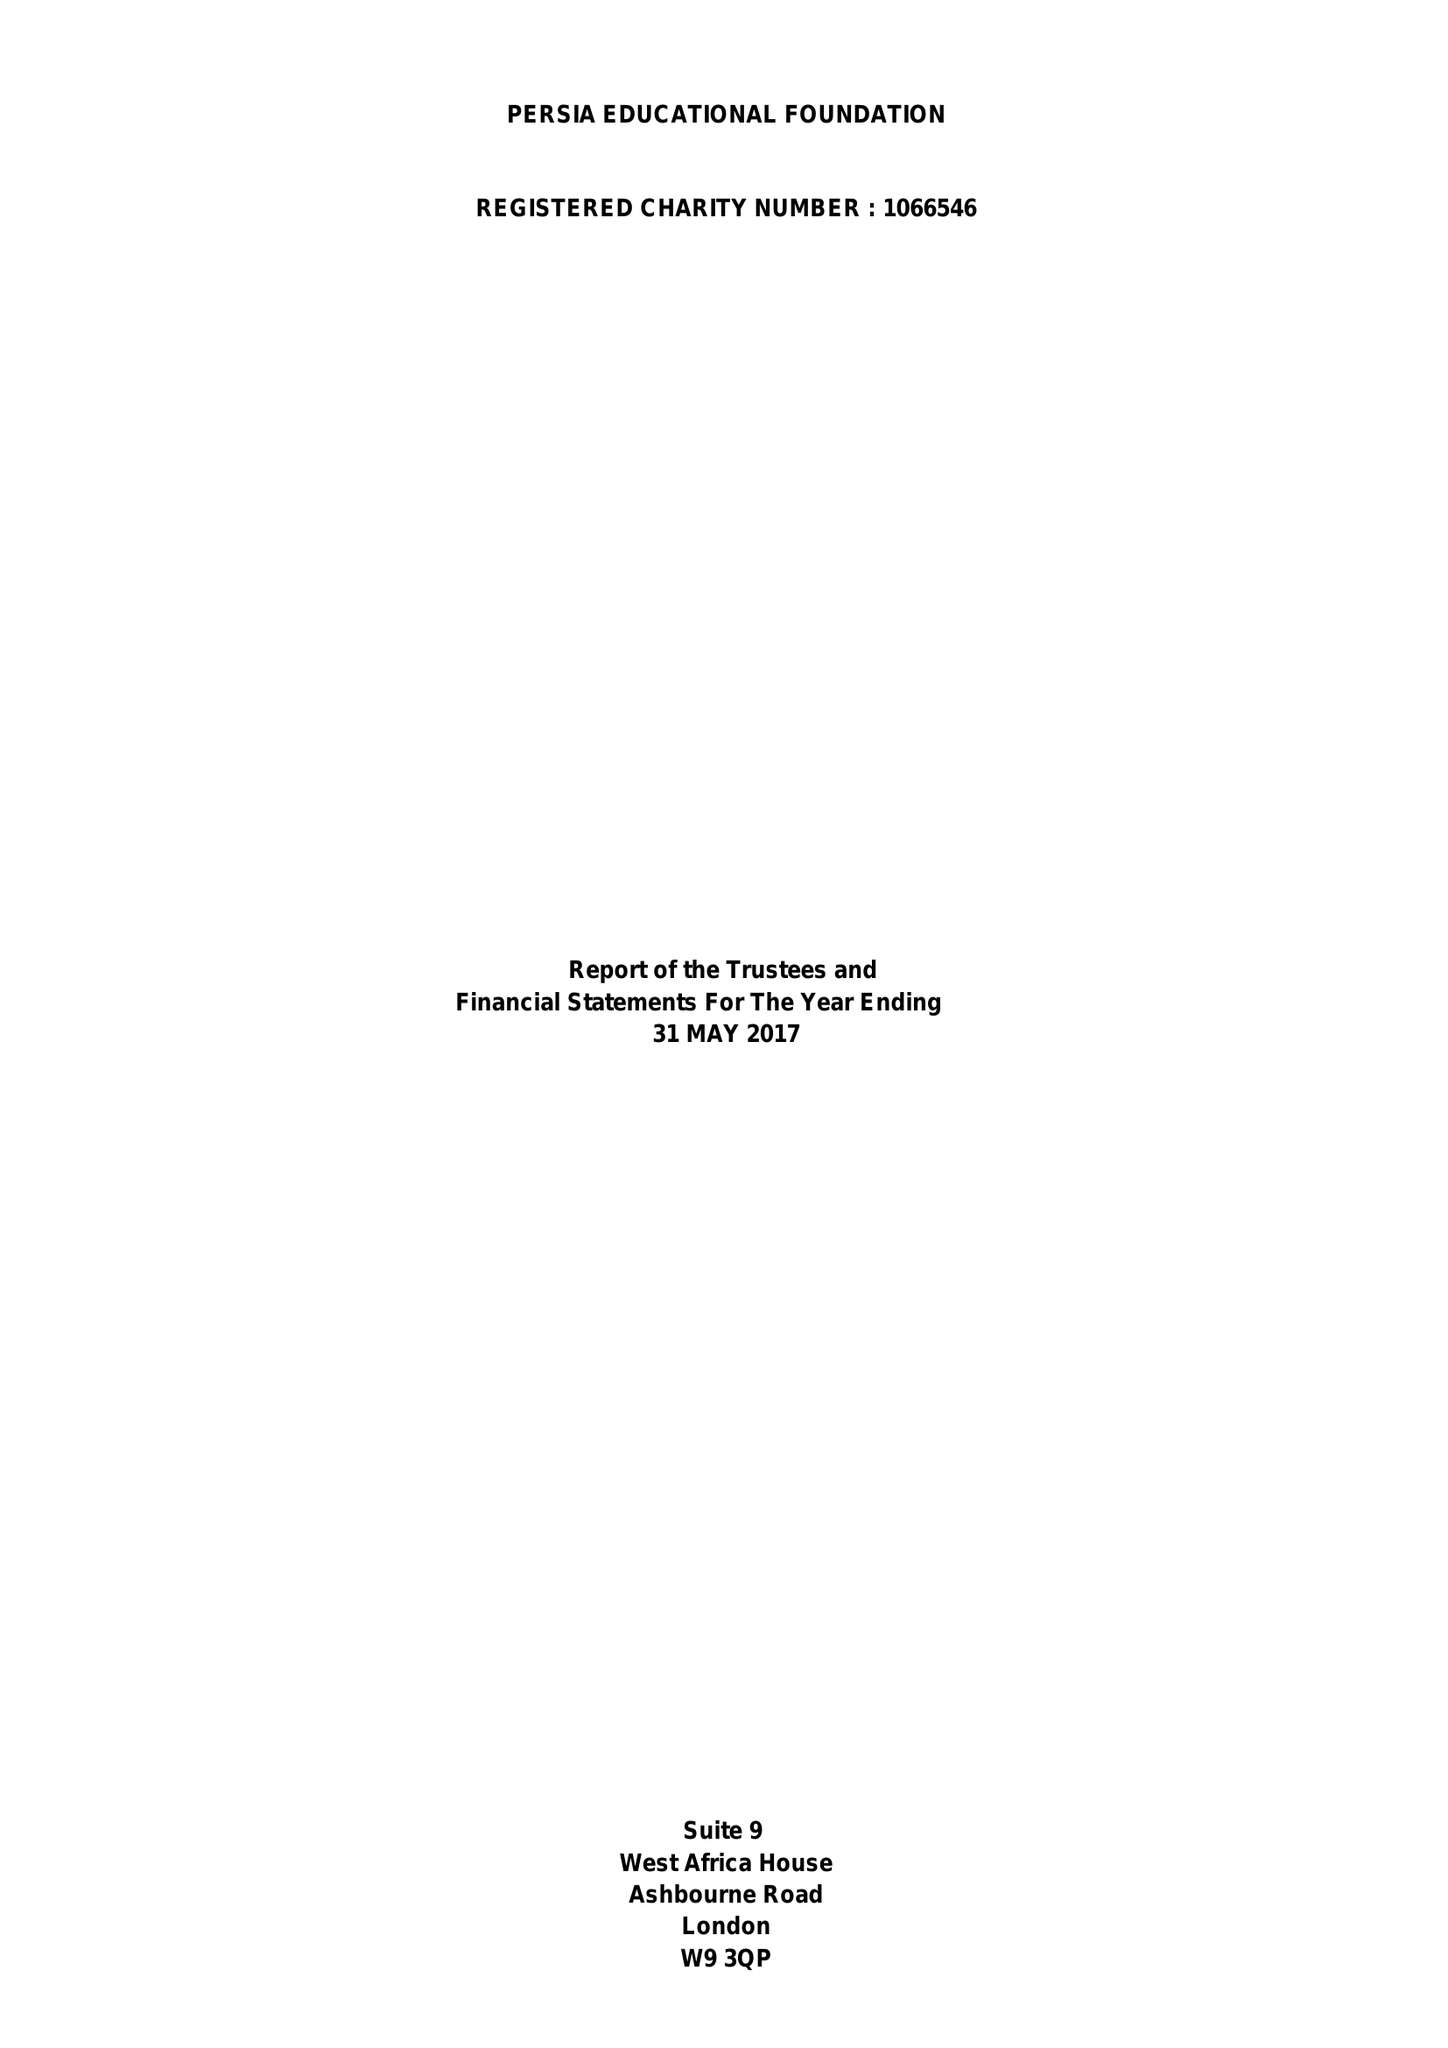What is the value for the address__post_town?
Answer the question using a single word or phrase. LONDON 